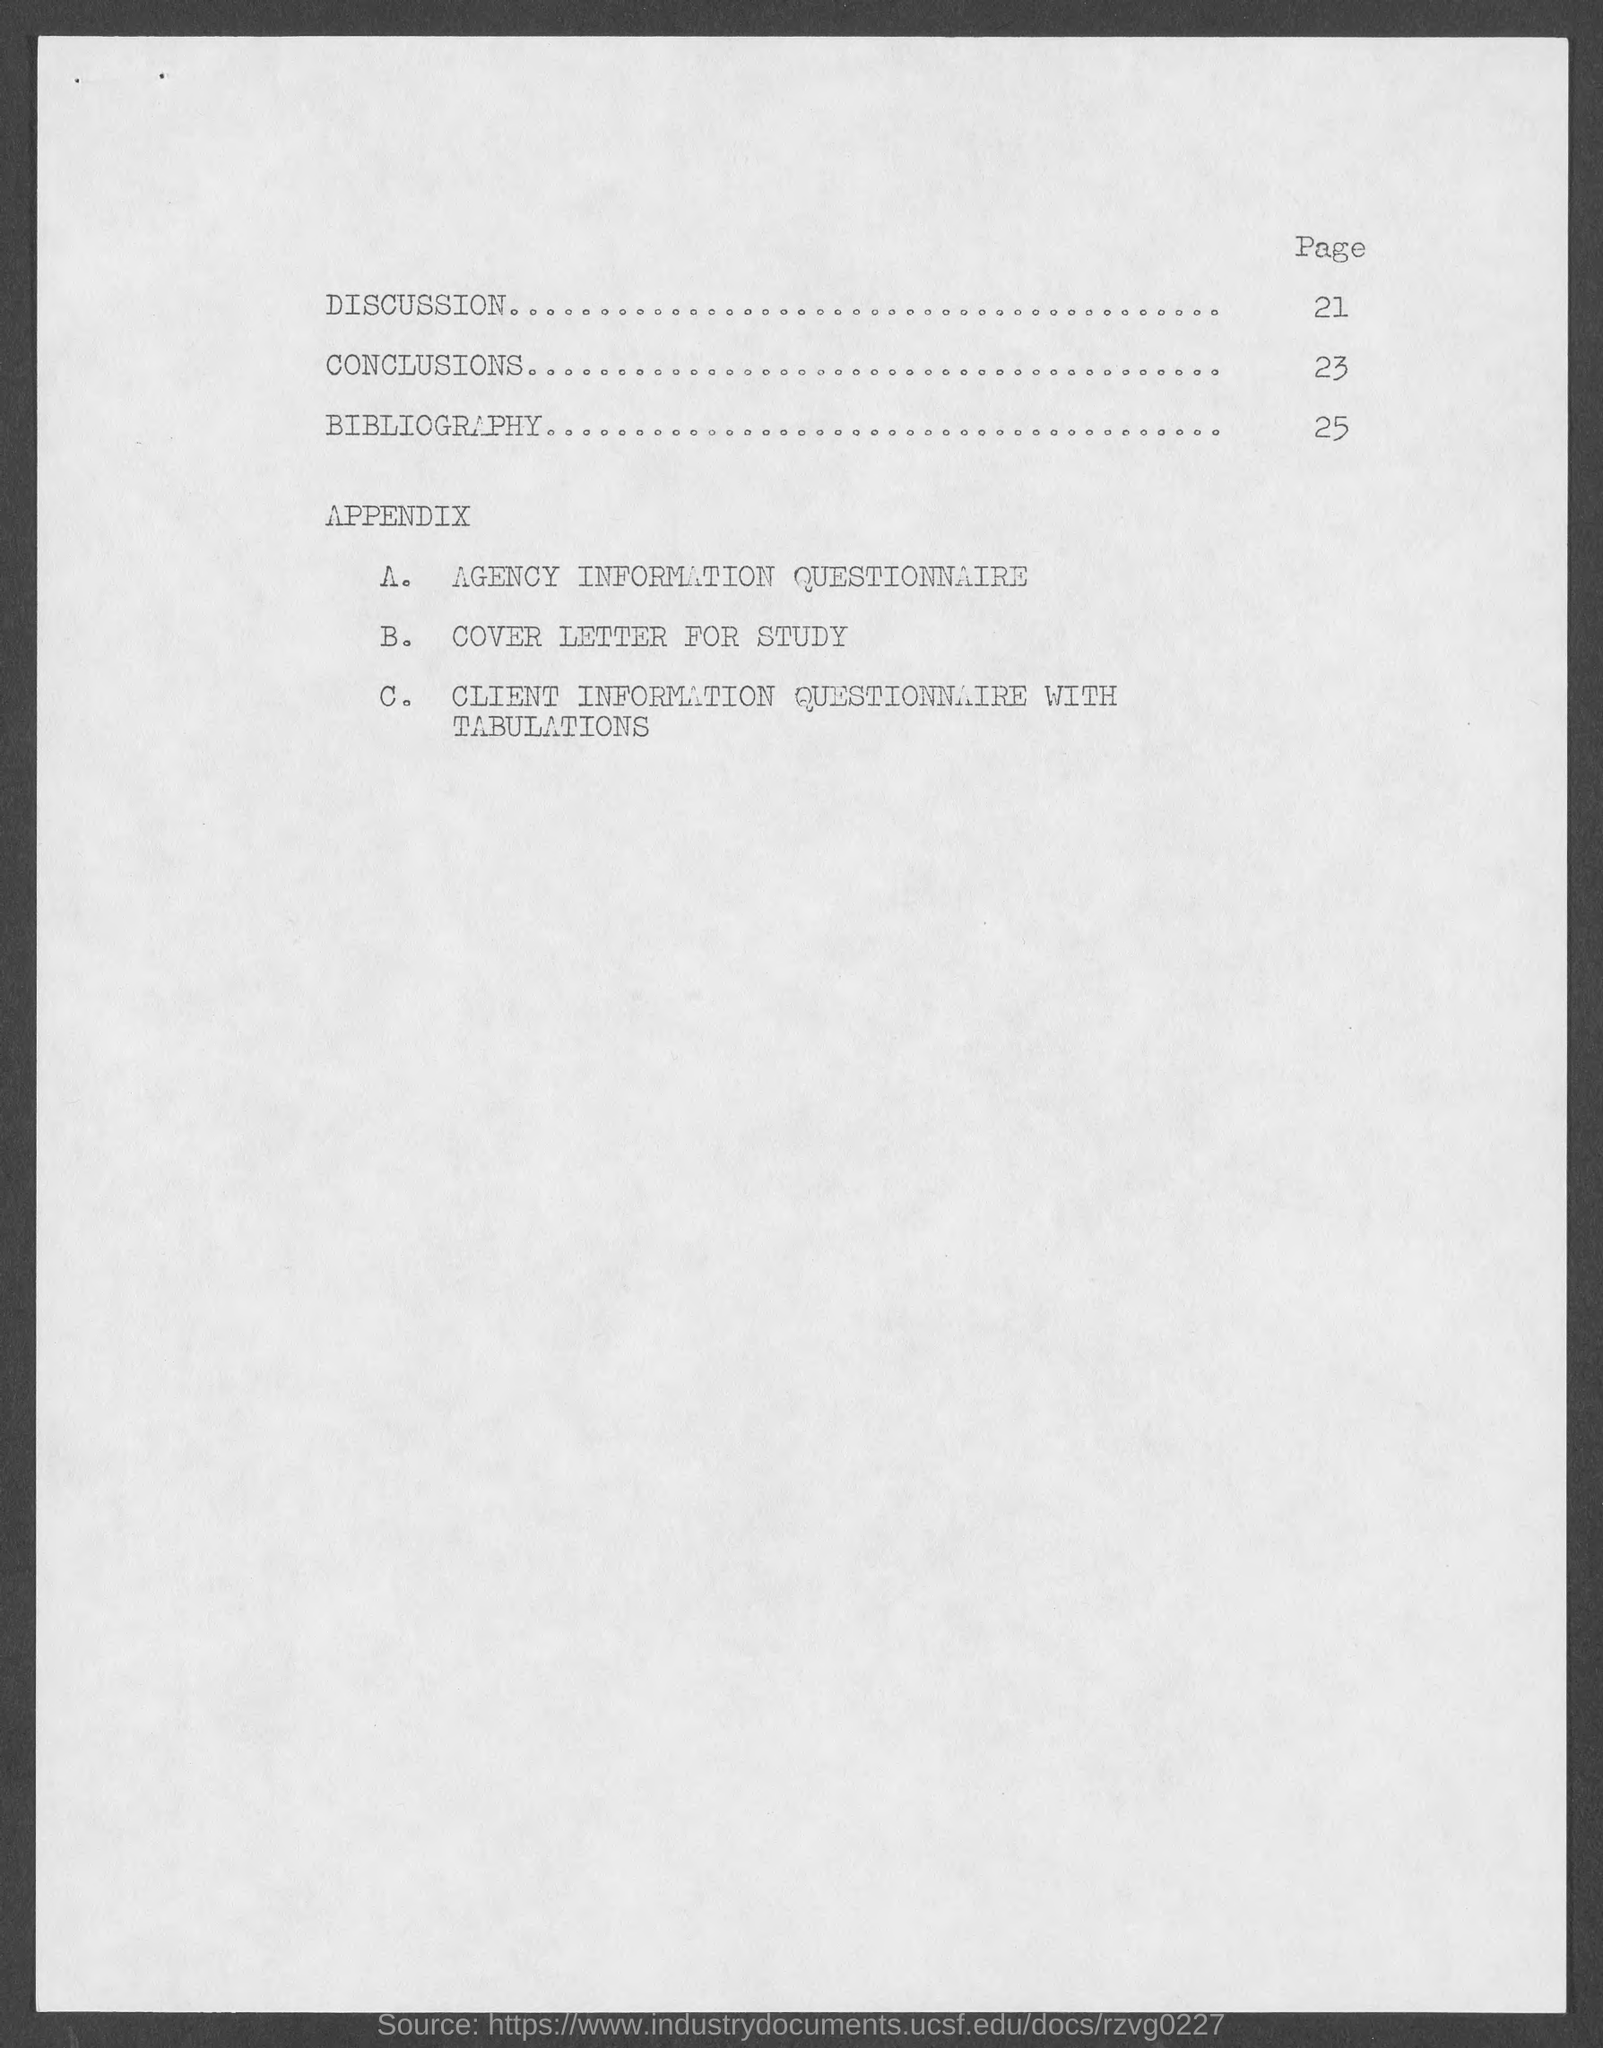Draw attention to some important aspects in this diagram. The page number for the Conclusion is 23. The page number for Discussion is 21. The specific page number for the bibliography is 25. 